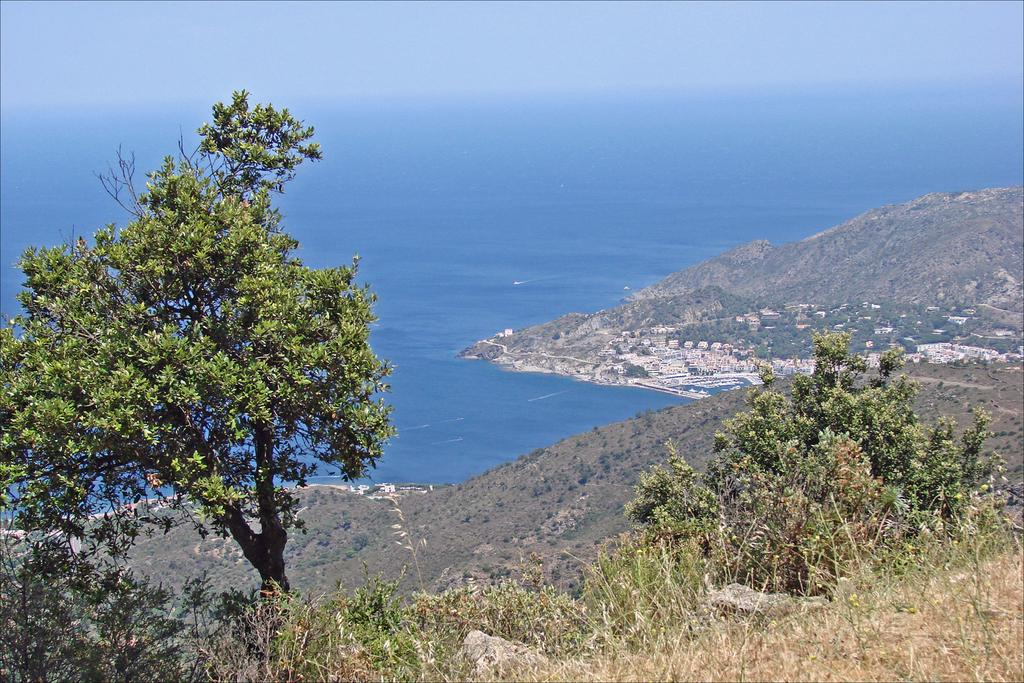What type of vegetation can be seen on the hill in the image? There is a tree and plants on a hill in the image. What can be seen in the distance behind the hill? There are hills visible in the background of the image. What natural feature is located beyond the hills in the image? There is an ocean in the background of the image. What color is the water in the ocean? The water in the ocean is blue. What part of the sky is visible in the image? The sky is visible in the image. What type of polish is being applied to the rail in the image? There is no rail or polish present in the image. How much sugar is dissolved in the water of the ocean in the image? There is no sugar present in the image, as it is a natural ocean. 